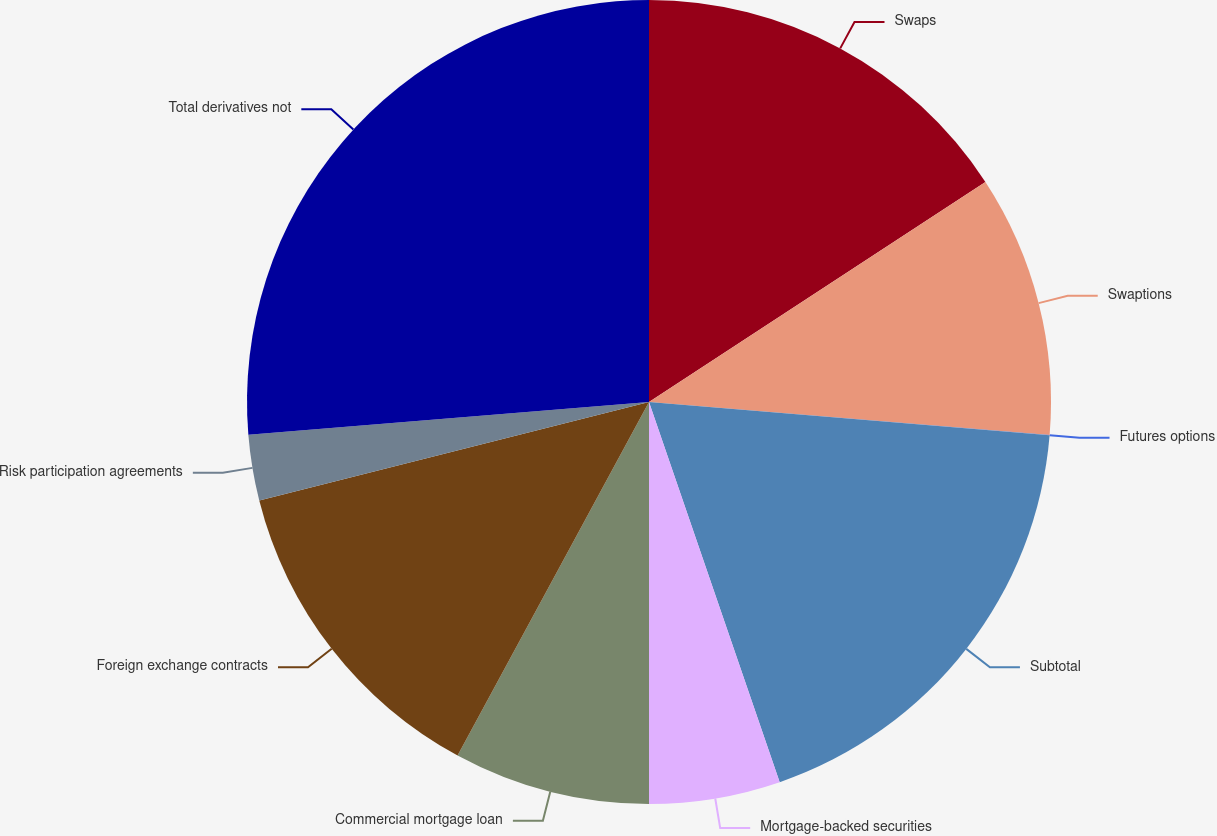<chart> <loc_0><loc_0><loc_500><loc_500><pie_chart><fcel>Swaps<fcel>Swaptions<fcel>Futures options<fcel>Subtotal<fcel>Mortgage-backed securities<fcel>Commercial mortgage loan<fcel>Foreign exchange contracts<fcel>Risk participation agreements<fcel>Total derivatives not<nl><fcel>15.78%<fcel>10.53%<fcel>0.01%<fcel>18.41%<fcel>5.27%<fcel>7.9%<fcel>13.16%<fcel>2.64%<fcel>26.3%<nl></chart> 